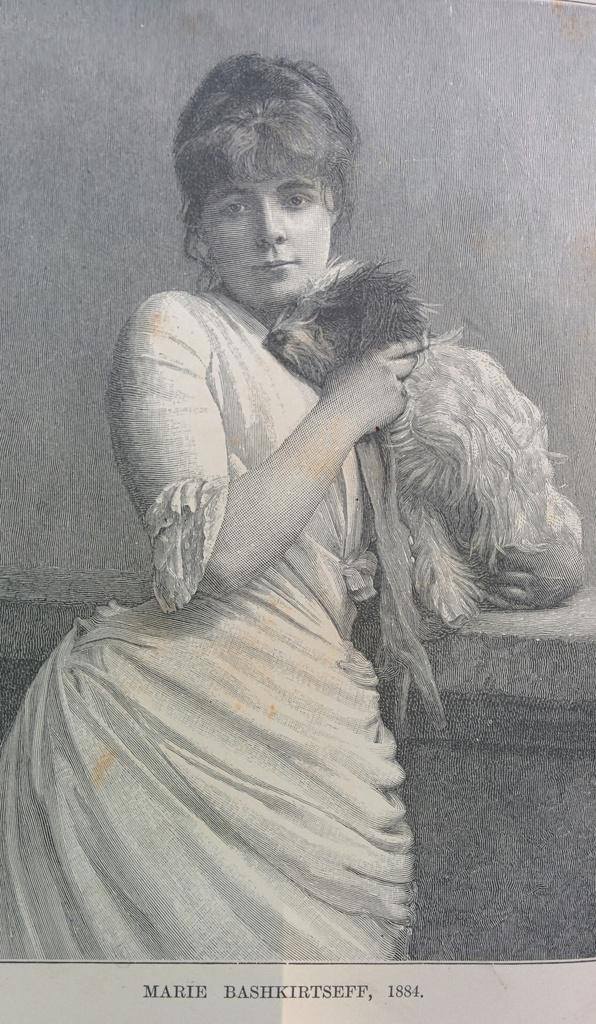What is the color scheme of the image? The image is black and white. Who is present in the image? There is a woman in the image. What is the woman holding in the image? The woman is holding a dog. What is the woman wearing in the image? The woman is wearing a white dress. How many legs does the dog have in the image? The provided facts do not mention the number of legs the dog has, so it cannot be determined from the image. 